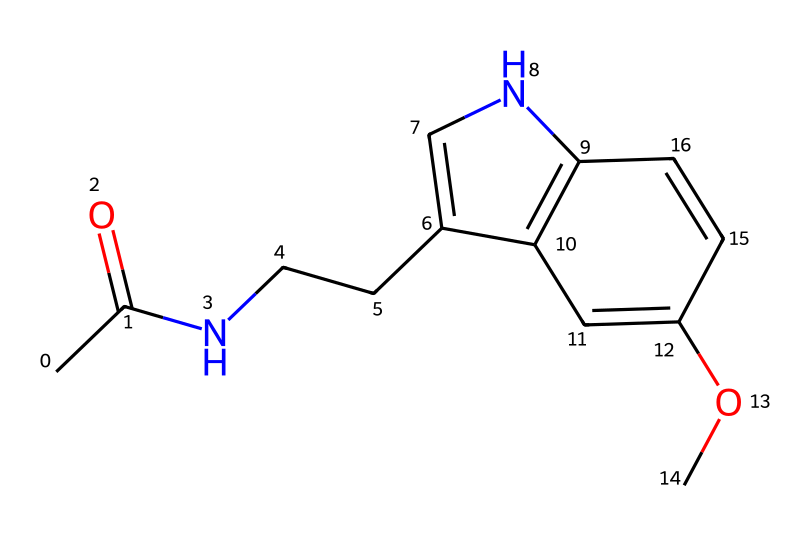What is the molecular formula of melatonin based on its structure? By analyzing the molecular structure, we can count the different types of atoms present. The chemical contains 13 carbon atoms, 16 hydrogen atoms, 2 nitrogen atoms, and 1 oxygen atom, leading to the formula C13H16N2O.
Answer: C13H16N2O How many rings are present in the structure of melatonin? Upon examining the structure, we can see there are two distinct cyclic (ring) structures: one is a six-membered ring and another is a five-membered ring. Thus, the total ring count is two.
Answer: 2 What type of functional group is present in melatonin? Looking at the structure, we can identify the presence of an amide group (due to the -CONH- part of the molecule) and an ether group (due to the -O- in the methoxy part). However, the most prominent functional group relevant to its classification is the amide.
Answer: amide What is the total number of nitrogen atoms in melatonin? By inspecting the structure, we can see there are two nitrogen atoms attached to the cyclic portions of the molecule, one in each of the rings.
Answer: 2 What does the methoxy group in melatonin contribute to its properties? The methoxy group (-OCH3) enhances the compound's lipophilicity, allowing it to cross biological membranes more easily, thereby influencing its effectiveness as a hormone that regulates sleep.
Answer: lipophilicity Does melatonin have any geometric isomers given its structure? The presence of double bonds in the structure can lead to cis/trans isomerism, particularly around the C=C bonds. Since there are two such double bonds, the compound can potentially exhibit geometric isomers.
Answer: Yes 